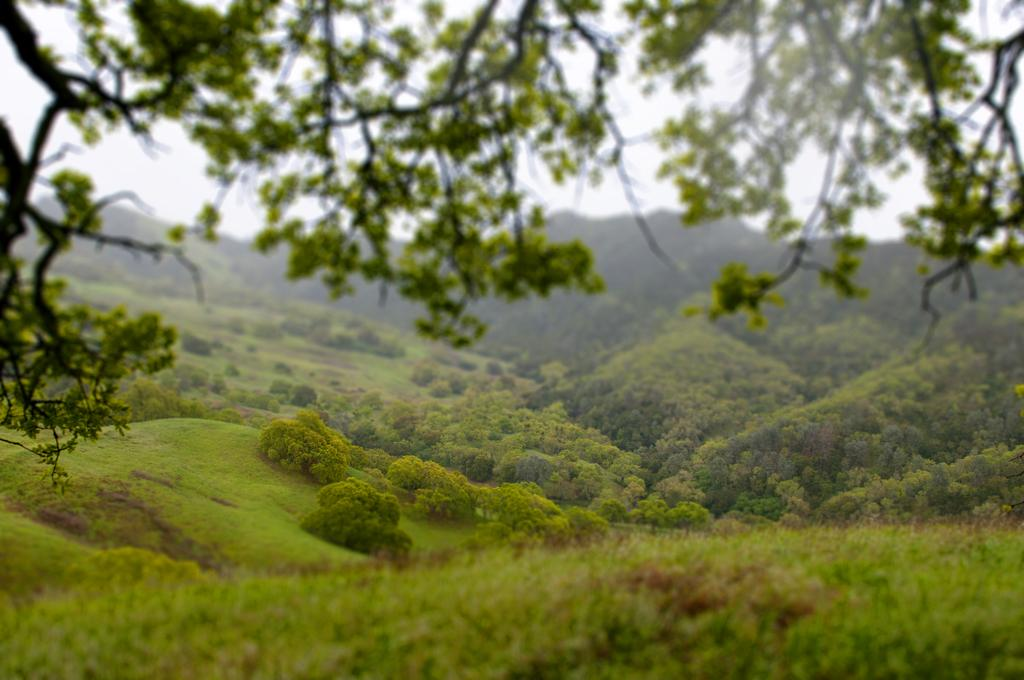What type of vegetation is present in the image? There are trees with branches and leaves in the image. Can you describe the terrain in the image? The trees may be on hills, suggesting a hilly landscape. What is visible at the bottom of the image? There is green grass at the bottom of the image. How many toes can be seen on the notebook in the image? There is no notebook present in the image, and therefore no toes can be seen on it. 